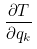Convert formula to latex. <formula><loc_0><loc_0><loc_500><loc_500>\frac { \partial T } { \partial q _ { k } }</formula> 